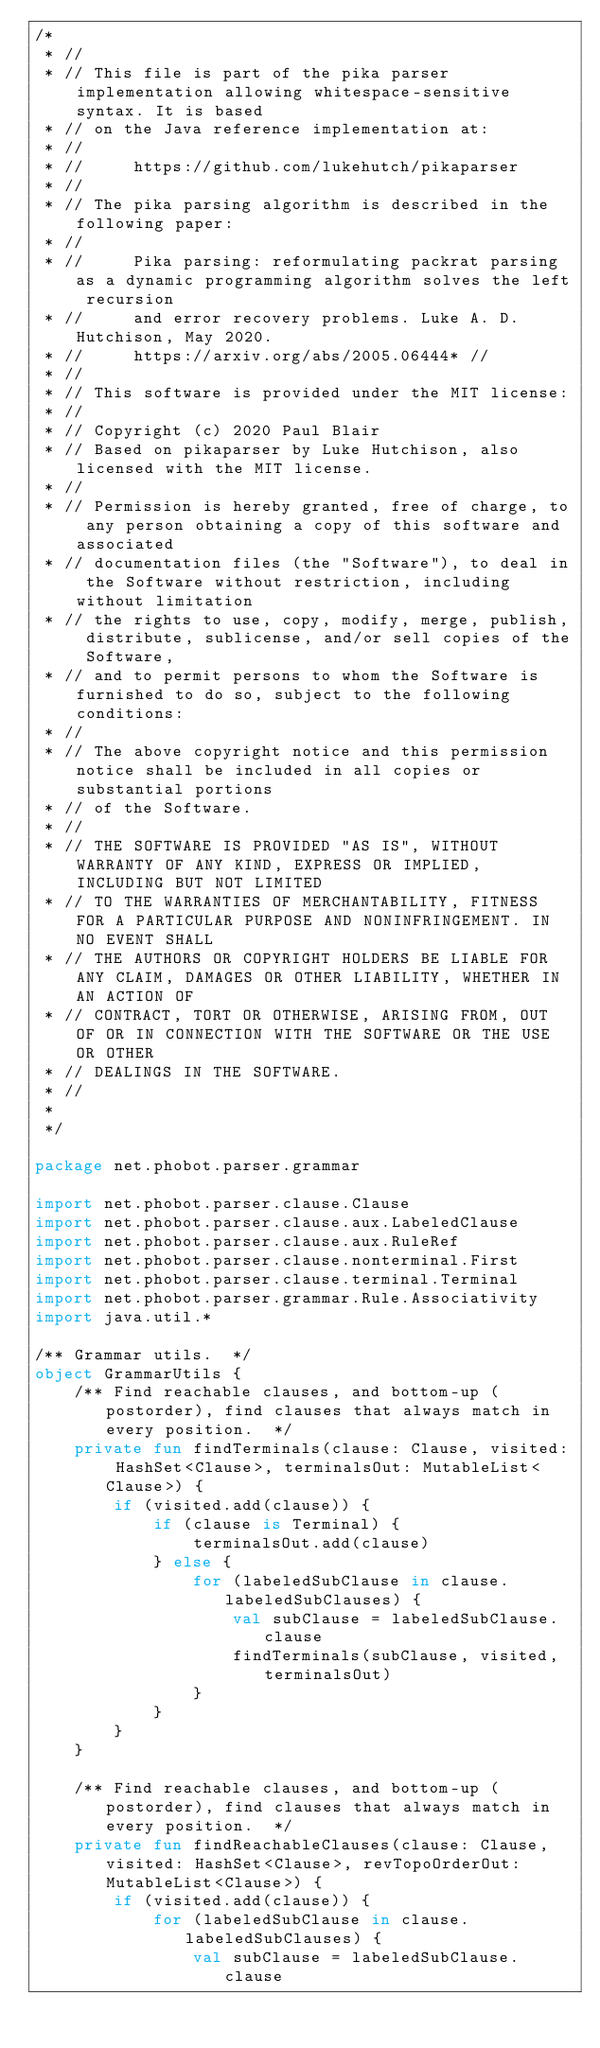Convert code to text. <code><loc_0><loc_0><loc_500><loc_500><_Kotlin_>/*
 * //
 * // This file is part of the pika parser implementation allowing whitespace-sensitive syntax. It is based
 * // on the Java reference implementation at:
 * //
 * //     https://github.com/lukehutch/pikaparser
 * //
 * // The pika parsing algorithm is described in the following paper:
 * //
 * //     Pika parsing: reformulating packrat parsing as a dynamic programming algorithm solves the left recursion
 * //     and error recovery problems. Luke A. D. Hutchison, May 2020.
 * //     https://arxiv.org/abs/2005.06444* //
 * //
 * // This software is provided under the MIT license:
 * //
 * // Copyright (c) 2020 Paul Blair
 * // Based on pikaparser by Luke Hutchison, also licensed with the MIT license.
 * //
 * // Permission is hereby granted, free of charge, to any person obtaining a copy of this software and associated
 * // documentation files (the "Software"), to deal in the Software without restriction, including without limitation
 * // the rights to use, copy, modify, merge, publish, distribute, sublicense, and/or sell copies of the Software,
 * // and to permit persons to whom the Software is furnished to do so, subject to the following conditions:
 * //
 * // The above copyright notice and this permission notice shall be included in all copies or substantial portions
 * // of the Software.
 * //
 * // THE SOFTWARE IS PROVIDED "AS IS", WITHOUT WARRANTY OF ANY KIND, EXPRESS OR IMPLIED, INCLUDING BUT NOT LIMITED
 * // TO THE WARRANTIES OF MERCHANTABILITY, FITNESS FOR A PARTICULAR PURPOSE AND NONINFRINGEMENT. IN NO EVENT SHALL
 * // THE AUTHORS OR COPYRIGHT HOLDERS BE LIABLE FOR ANY CLAIM, DAMAGES OR OTHER LIABILITY, WHETHER IN AN ACTION OF
 * // CONTRACT, TORT OR OTHERWISE, ARISING FROM, OUT OF OR IN CONNECTION WITH THE SOFTWARE OR THE USE OR OTHER
 * // DEALINGS IN THE SOFTWARE.
 * //
 *
 */

package net.phobot.parser.grammar

import net.phobot.parser.clause.Clause
import net.phobot.parser.clause.aux.LabeledClause
import net.phobot.parser.clause.aux.RuleRef
import net.phobot.parser.clause.nonterminal.First
import net.phobot.parser.clause.terminal.Terminal
import net.phobot.parser.grammar.Rule.Associativity
import java.util.*

/** Grammar utils.  */
object GrammarUtils {
    /** Find reachable clauses, and bottom-up (postorder), find clauses that always match in every position.  */
    private fun findTerminals(clause: Clause, visited: HashSet<Clause>, terminalsOut: MutableList<Clause>) {
        if (visited.add(clause)) {
            if (clause is Terminal) {
                terminalsOut.add(clause)
            } else {
                for (labeledSubClause in clause.labeledSubClauses) {
                    val subClause = labeledSubClause.clause
                    findTerminals(subClause, visited, terminalsOut)
                }
            }
        }
    }

    /** Find reachable clauses, and bottom-up (postorder), find clauses that always match in every position.  */
    private fun findReachableClauses(clause: Clause, visited: HashSet<Clause>, revTopoOrderOut: MutableList<Clause>) {
        if (visited.add(clause)) {
            for (labeledSubClause in clause.labeledSubClauses) {
                val subClause = labeledSubClause.clause</code> 